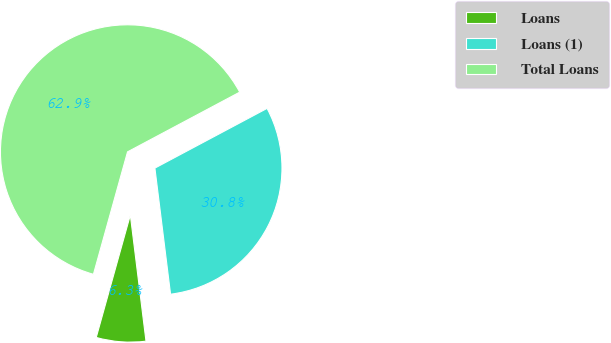Convert chart to OTSL. <chart><loc_0><loc_0><loc_500><loc_500><pie_chart><fcel>Loans<fcel>Loans (1)<fcel>Total Loans<nl><fcel>6.29%<fcel>30.82%<fcel>62.89%<nl></chart> 